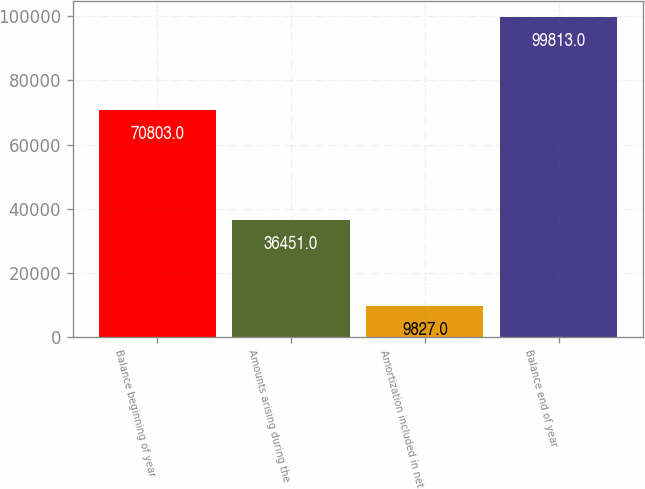Convert chart. <chart><loc_0><loc_0><loc_500><loc_500><bar_chart><fcel>Balance beginning of year<fcel>Amounts arising during the<fcel>Amortization included in net<fcel>Balance end of year<nl><fcel>70803<fcel>36451<fcel>9827<fcel>99813<nl></chart> 